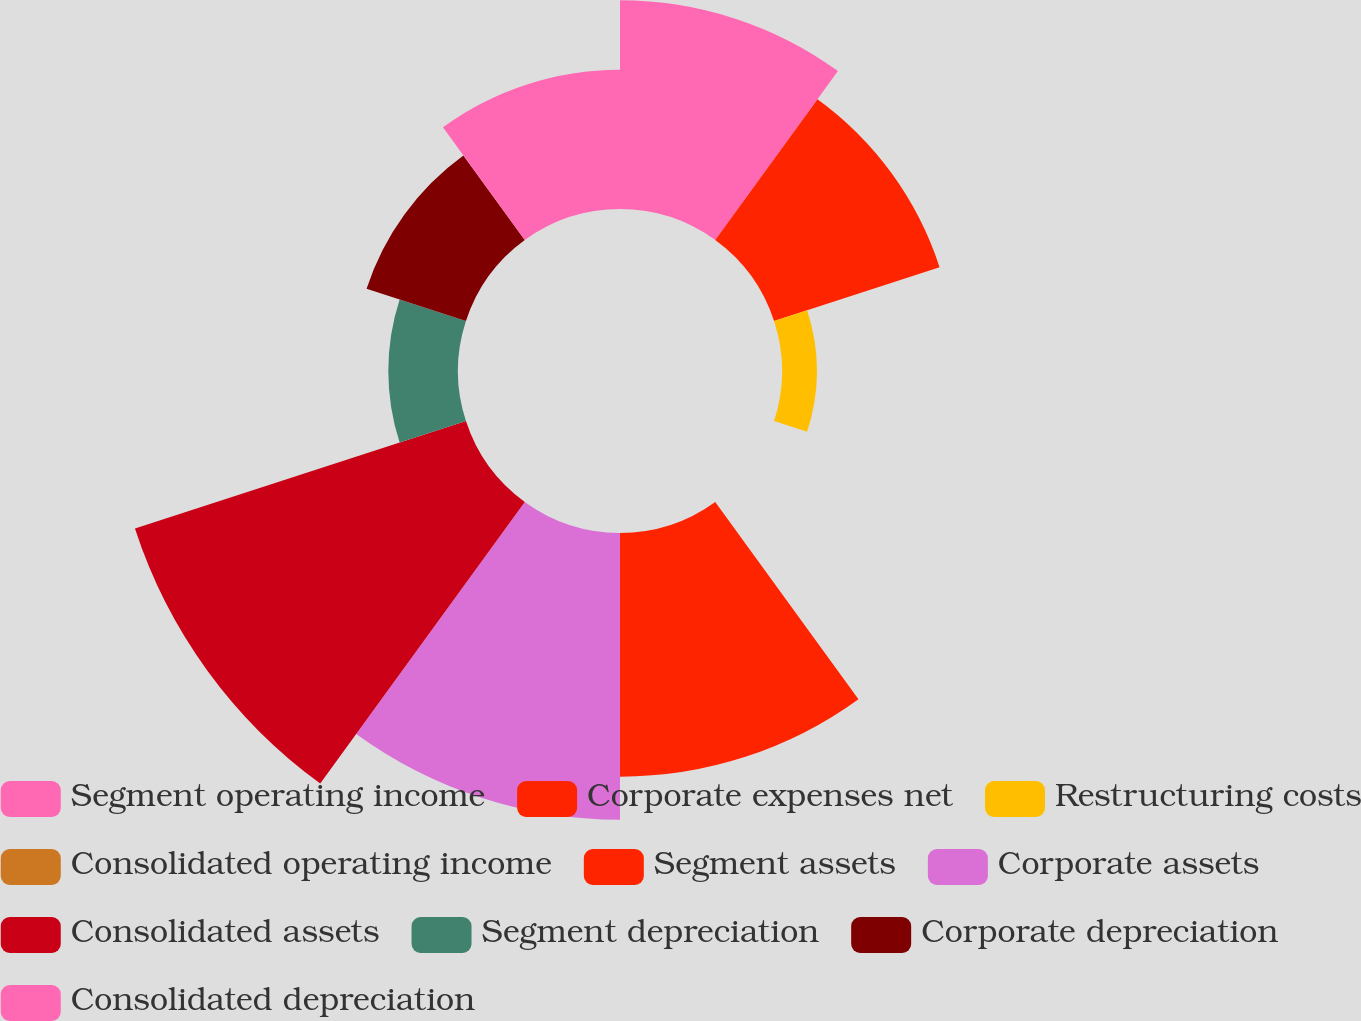Convert chart. <chart><loc_0><loc_0><loc_500><loc_500><pie_chart><fcel>Segment operating income<fcel>Corporate expenses net<fcel>Restructuring costs<fcel>Consolidated operating income<fcel>Segment assets<fcel>Corporate assets<fcel>Consolidated assets<fcel>Segment depreciation<fcel>Corporate depreciation<fcel>Consolidated depreciation<nl><fcel>12.97%<fcel>10.81%<fcel>2.16%<fcel>0.0%<fcel>15.14%<fcel>17.82%<fcel>21.62%<fcel>4.33%<fcel>6.49%<fcel>8.65%<nl></chart> 